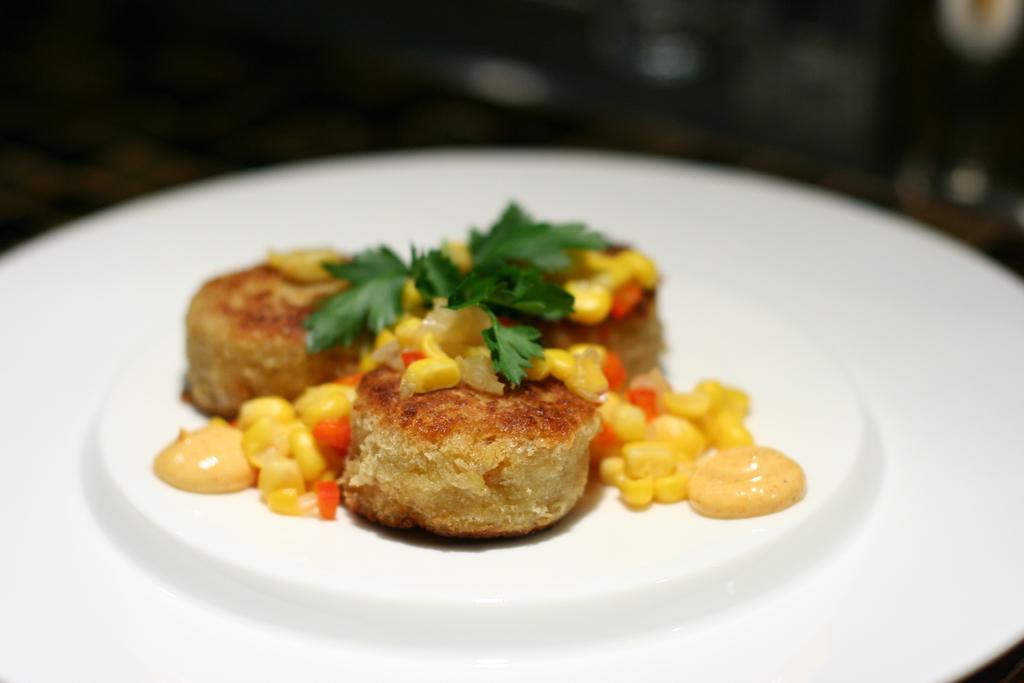Could you give a brief overview of what you see in this image? There are leaves on the cakes which are on the white color plate, on which there are seeds and cream. And the background is dark in color. 